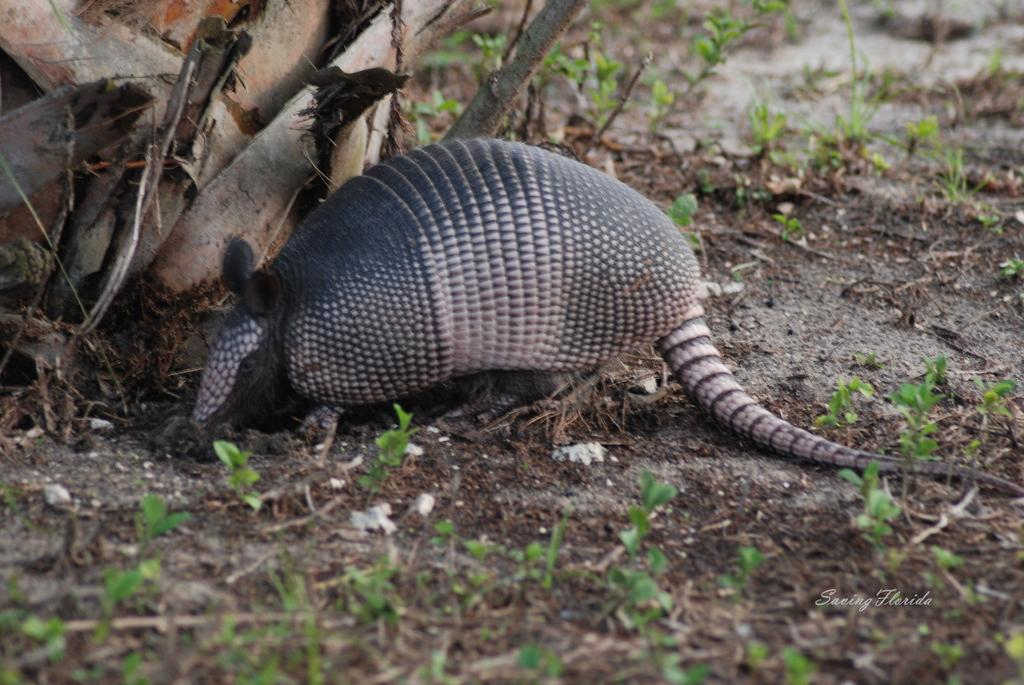What type of animal can be seen in the picture? There is an animal in the picture, but its specific type cannot be determined from the provided facts. Where is the animal located in the picture? The animal is on the ground in the picture. What type of vegetation is visible in the picture? There is grass visible in the picture. What else can be seen in the picture besides the animal and grass? There are other objects in the picture, but their specific nature cannot be determined from the provided facts. What is the purpose of the bone in the picture? There is no bone present in the picture, so it is not possible to determine its purpose. 